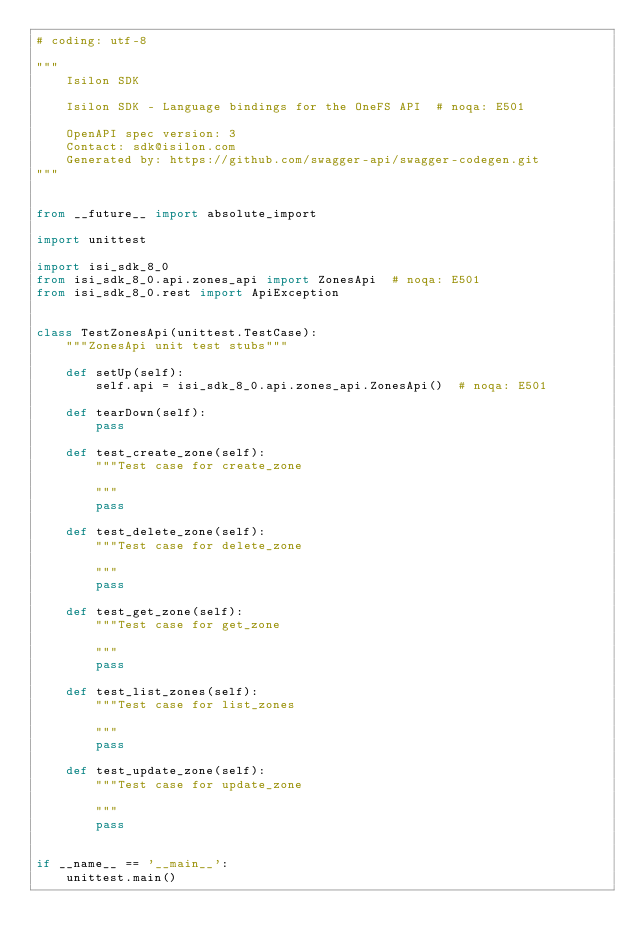Convert code to text. <code><loc_0><loc_0><loc_500><loc_500><_Python_># coding: utf-8

"""
    Isilon SDK

    Isilon SDK - Language bindings for the OneFS API  # noqa: E501

    OpenAPI spec version: 3
    Contact: sdk@isilon.com
    Generated by: https://github.com/swagger-api/swagger-codegen.git
"""


from __future__ import absolute_import

import unittest

import isi_sdk_8_0
from isi_sdk_8_0.api.zones_api import ZonesApi  # noqa: E501
from isi_sdk_8_0.rest import ApiException


class TestZonesApi(unittest.TestCase):
    """ZonesApi unit test stubs"""

    def setUp(self):
        self.api = isi_sdk_8_0.api.zones_api.ZonesApi()  # noqa: E501

    def tearDown(self):
        pass

    def test_create_zone(self):
        """Test case for create_zone

        """
        pass

    def test_delete_zone(self):
        """Test case for delete_zone

        """
        pass

    def test_get_zone(self):
        """Test case for get_zone

        """
        pass

    def test_list_zones(self):
        """Test case for list_zones

        """
        pass

    def test_update_zone(self):
        """Test case for update_zone

        """
        pass


if __name__ == '__main__':
    unittest.main()
</code> 